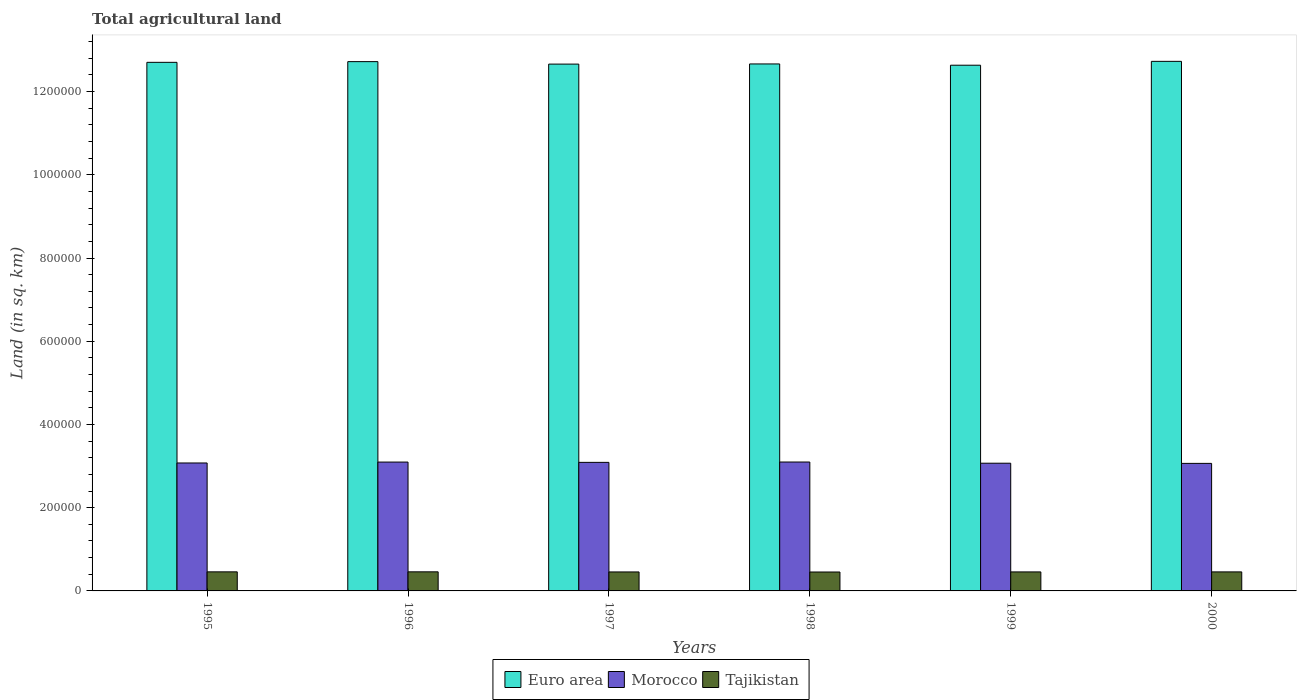How many groups of bars are there?
Provide a succinct answer. 6. Are the number of bars per tick equal to the number of legend labels?
Your answer should be very brief. Yes. Are the number of bars on each tick of the X-axis equal?
Your answer should be compact. Yes. How many bars are there on the 1st tick from the left?
Make the answer very short. 3. In how many cases, is the number of bars for a given year not equal to the number of legend labels?
Give a very brief answer. 0. What is the total agricultural land in Morocco in 2000?
Give a very brief answer. 3.07e+05. Across all years, what is the maximum total agricultural land in Tajikistan?
Make the answer very short. 4.58e+04. Across all years, what is the minimum total agricultural land in Morocco?
Your response must be concise. 3.07e+05. In which year was the total agricultural land in Tajikistan maximum?
Your response must be concise. 1996. In which year was the total agricultural land in Morocco minimum?
Give a very brief answer. 2000. What is the total total agricultural land in Morocco in the graph?
Ensure brevity in your answer.  1.85e+06. What is the difference between the total agricultural land in Morocco in 1995 and that in 1996?
Your answer should be very brief. -2170. What is the difference between the total agricultural land in Euro area in 1999 and the total agricultural land in Morocco in 1995?
Offer a very short reply. 9.56e+05. What is the average total agricultural land in Morocco per year?
Offer a terse response. 3.08e+05. In the year 1998, what is the difference between the total agricultural land in Euro area and total agricultural land in Tajikistan?
Ensure brevity in your answer.  1.22e+06. In how many years, is the total agricultural land in Morocco greater than 680000 sq.km?
Provide a short and direct response. 0. What is the ratio of the total agricultural land in Tajikistan in 1995 to that in 1996?
Keep it short and to the point. 1. Is the difference between the total agricultural land in Euro area in 1995 and 1999 greater than the difference between the total agricultural land in Tajikistan in 1995 and 1999?
Provide a succinct answer. Yes. What is the difference between the highest and the second highest total agricultural land in Euro area?
Keep it short and to the point. 653. What is the difference between the highest and the lowest total agricultural land in Euro area?
Offer a terse response. 9261. In how many years, is the total agricultural land in Morocco greater than the average total agricultural land in Morocco taken over all years?
Give a very brief answer. 3. What does the 3rd bar from the left in 1998 represents?
Offer a terse response. Tajikistan. Is it the case that in every year, the sum of the total agricultural land in Tajikistan and total agricultural land in Morocco is greater than the total agricultural land in Euro area?
Your answer should be compact. No. How many bars are there?
Provide a short and direct response. 18. How many years are there in the graph?
Give a very brief answer. 6. Does the graph contain grids?
Keep it short and to the point. No. How many legend labels are there?
Make the answer very short. 3. How are the legend labels stacked?
Provide a succinct answer. Horizontal. What is the title of the graph?
Your response must be concise. Total agricultural land. What is the label or title of the X-axis?
Provide a short and direct response. Years. What is the label or title of the Y-axis?
Your response must be concise. Land (in sq. km). What is the Land (in sq. km) in Euro area in 1995?
Your answer should be very brief. 1.27e+06. What is the Land (in sq. km) of Morocco in 1995?
Provide a short and direct response. 3.07e+05. What is the Land (in sq. km) in Tajikistan in 1995?
Keep it short and to the point. 4.58e+04. What is the Land (in sq. km) in Euro area in 1996?
Your answer should be very brief. 1.27e+06. What is the Land (in sq. km) of Morocco in 1996?
Offer a terse response. 3.10e+05. What is the Land (in sq. km) of Tajikistan in 1996?
Keep it short and to the point. 4.58e+04. What is the Land (in sq. km) of Euro area in 1997?
Your answer should be very brief. 1.27e+06. What is the Land (in sq. km) of Morocco in 1997?
Provide a short and direct response. 3.09e+05. What is the Land (in sq. km) in Tajikistan in 1997?
Your answer should be very brief. 4.56e+04. What is the Land (in sq. km) of Euro area in 1998?
Provide a succinct answer. 1.27e+06. What is the Land (in sq. km) of Morocco in 1998?
Your answer should be very brief. 3.10e+05. What is the Land (in sq. km) in Tajikistan in 1998?
Make the answer very short. 4.55e+04. What is the Land (in sq. km) in Euro area in 1999?
Your response must be concise. 1.26e+06. What is the Land (in sq. km) in Morocco in 1999?
Provide a succinct answer. 3.07e+05. What is the Land (in sq. km) of Tajikistan in 1999?
Provide a succinct answer. 4.57e+04. What is the Land (in sq. km) of Euro area in 2000?
Offer a terse response. 1.27e+06. What is the Land (in sq. km) in Morocco in 2000?
Ensure brevity in your answer.  3.07e+05. What is the Land (in sq. km) in Tajikistan in 2000?
Your answer should be very brief. 4.57e+04. Across all years, what is the maximum Land (in sq. km) in Euro area?
Provide a short and direct response. 1.27e+06. Across all years, what is the maximum Land (in sq. km) of Morocco?
Your answer should be very brief. 3.10e+05. Across all years, what is the maximum Land (in sq. km) of Tajikistan?
Offer a very short reply. 4.58e+04. Across all years, what is the minimum Land (in sq. km) of Euro area?
Ensure brevity in your answer.  1.26e+06. Across all years, what is the minimum Land (in sq. km) of Morocco?
Give a very brief answer. 3.07e+05. Across all years, what is the minimum Land (in sq. km) of Tajikistan?
Keep it short and to the point. 4.55e+04. What is the total Land (in sq. km) in Euro area in the graph?
Provide a short and direct response. 7.61e+06. What is the total Land (in sq. km) of Morocco in the graph?
Make the answer very short. 1.85e+06. What is the total Land (in sq. km) of Tajikistan in the graph?
Provide a succinct answer. 2.74e+05. What is the difference between the Land (in sq. km) of Euro area in 1995 and that in 1996?
Your response must be concise. -1692. What is the difference between the Land (in sq. km) in Morocco in 1995 and that in 1996?
Your answer should be compact. -2170. What is the difference between the Land (in sq. km) of Euro area in 1995 and that in 1997?
Ensure brevity in your answer.  4275. What is the difference between the Land (in sq. km) in Morocco in 1995 and that in 1997?
Your answer should be very brief. -1460. What is the difference between the Land (in sq. km) in Euro area in 1995 and that in 1998?
Keep it short and to the point. 3881. What is the difference between the Land (in sq. km) of Morocco in 1995 and that in 1998?
Keep it short and to the point. -2270. What is the difference between the Land (in sq. km) of Tajikistan in 1995 and that in 1998?
Provide a succinct answer. 350. What is the difference between the Land (in sq. km) in Euro area in 1995 and that in 1999?
Your answer should be compact. 6916. What is the difference between the Land (in sq. km) of Morocco in 1995 and that in 1999?
Give a very brief answer. 560. What is the difference between the Land (in sq. km) in Tajikistan in 1995 and that in 1999?
Make the answer very short. 140. What is the difference between the Land (in sq. km) in Euro area in 1995 and that in 2000?
Give a very brief answer. -2345. What is the difference between the Land (in sq. km) in Morocco in 1995 and that in 2000?
Your response must be concise. 970. What is the difference between the Land (in sq. km) of Euro area in 1996 and that in 1997?
Ensure brevity in your answer.  5967. What is the difference between the Land (in sq. km) in Morocco in 1996 and that in 1997?
Offer a terse response. 710. What is the difference between the Land (in sq. km) of Tajikistan in 1996 and that in 1997?
Give a very brief answer. 230. What is the difference between the Land (in sq. km) of Euro area in 1996 and that in 1998?
Provide a short and direct response. 5573. What is the difference between the Land (in sq. km) in Morocco in 1996 and that in 1998?
Make the answer very short. -100. What is the difference between the Land (in sq. km) in Tajikistan in 1996 and that in 1998?
Your answer should be compact. 380. What is the difference between the Land (in sq. km) in Euro area in 1996 and that in 1999?
Offer a terse response. 8608. What is the difference between the Land (in sq. km) in Morocco in 1996 and that in 1999?
Your answer should be compact. 2730. What is the difference between the Land (in sq. km) in Tajikistan in 1996 and that in 1999?
Provide a short and direct response. 170. What is the difference between the Land (in sq. km) in Euro area in 1996 and that in 2000?
Your response must be concise. -653. What is the difference between the Land (in sq. km) of Morocco in 1996 and that in 2000?
Provide a short and direct response. 3140. What is the difference between the Land (in sq. km) in Tajikistan in 1996 and that in 2000?
Keep it short and to the point. 120. What is the difference between the Land (in sq. km) in Euro area in 1997 and that in 1998?
Your response must be concise. -394. What is the difference between the Land (in sq. km) of Morocco in 1997 and that in 1998?
Your answer should be very brief. -810. What is the difference between the Land (in sq. km) of Tajikistan in 1997 and that in 1998?
Your answer should be compact. 150. What is the difference between the Land (in sq. km) of Euro area in 1997 and that in 1999?
Your response must be concise. 2641. What is the difference between the Land (in sq. km) in Morocco in 1997 and that in 1999?
Your answer should be very brief. 2020. What is the difference between the Land (in sq. km) in Tajikistan in 1997 and that in 1999?
Offer a very short reply. -60. What is the difference between the Land (in sq. km) in Euro area in 1997 and that in 2000?
Make the answer very short. -6620. What is the difference between the Land (in sq. km) of Morocco in 1997 and that in 2000?
Ensure brevity in your answer.  2430. What is the difference between the Land (in sq. km) in Tajikistan in 1997 and that in 2000?
Your answer should be very brief. -110. What is the difference between the Land (in sq. km) in Euro area in 1998 and that in 1999?
Keep it short and to the point. 3035. What is the difference between the Land (in sq. km) in Morocco in 1998 and that in 1999?
Keep it short and to the point. 2830. What is the difference between the Land (in sq. km) in Tajikistan in 1998 and that in 1999?
Your answer should be very brief. -210. What is the difference between the Land (in sq. km) of Euro area in 1998 and that in 2000?
Offer a very short reply. -6226. What is the difference between the Land (in sq. km) of Morocco in 1998 and that in 2000?
Make the answer very short. 3240. What is the difference between the Land (in sq. km) of Tajikistan in 1998 and that in 2000?
Provide a short and direct response. -260. What is the difference between the Land (in sq. km) of Euro area in 1999 and that in 2000?
Offer a very short reply. -9261. What is the difference between the Land (in sq. km) in Morocco in 1999 and that in 2000?
Keep it short and to the point. 410. What is the difference between the Land (in sq. km) of Tajikistan in 1999 and that in 2000?
Provide a short and direct response. -50. What is the difference between the Land (in sq. km) of Euro area in 1995 and the Land (in sq. km) of Morocco in 1996?
Make the answer very short. 9.61e+05. What is the difference between the Land (in sq. km) in Euro area in 1995 and the Land (in sq. km) in Tajikistan in 1996?
Give a very brief answer. 1.22e+06. What is the difference between the Land (in sq. km) in Morocco in 1995 and the Land (in sq. km) in Tajikistan in 1996?
Keep it short and to the point. 2.62e+05. What is the difference between the Land (in sq. km) in Euro area in 1995 and the Land (in sq. km) in Morocco in 1997?
Offer a very short reply. 9.61e+05. What is the difference between the Land (in sq. km) in Euro area in 1995 and the Land (in sq. km) in Tajikistan in 1997?
Ensure brevity in your answer.  1.22e+06. What is the difference between the Land (in sq. km) in Morocco in 1995 and the Land (in sq. km) in Tajikistan in 1997?
Your answer should be compact. 2.62e+05. What is the difference between the Land (in sq. km) of Euro area in 1995 and the Land (in sq. km) of Morocco in 1998?
Give a very brief answer. 9.61e+05. What is the difference between the Land (in sq. km) in Euro area in 1995 and the Land (in sq. km) in Tajikistan in 1998?
Your answer should be very brief. 1.22e+06. What is the difference between the Land (in sq. km) in Morocco in 1995 and the Land (in sq. km) in Tajikistan in 1998?
Your response must be concise. 2.62e+05. What is the difference between the Land (in sq. km) in Euro area in 1995 and the Land (in sq. km) in Morocco in 1999?
Provide a short and direct response. 9.63e+05. What is the difference between the Land (in sq. km) in Euro area in 1995 and the Land (in sq. km) in Tajikistan in 1999?
Make the answer very short. 1.22e+06. What is the difference between the Land (in sq. km) of Morocco in 1995 and the Land (in sq. km) of Tajikistan in 1999?
Your answer should be very brief. 2.62e+05. What is the difference between the Land (in sq. km) of Euro area in 1995 and the Land (in sq. km) of Morocco in 2000?
Keep it short and to the point. 9.64e+05. What is the difference between the Land (in sq. km) of Euro area in 1995 and the Land (in sq. km) of Tajikistan in 2000?
Provide a succinct answer. 1.22e+06. What is the difference between the Land (in sq. km) of Morocco in 1995 and the Land (in sq. km) of Tajikistan in 2000?
Offer a very short reply. 2.62e+05. What is the difference between the Land (in sq. km) in Euro area in 1996 and the Land (in sq. km) in Morocco in 1997?
Ensure brevity in your answer.  9.63e+05. What is the difference between the Land (in sq. km) of Euro area in 1996 and the Land (in sq. km) of Tajikistan in 1997?
Your response must be concise. 1.23e+06. What is the difference between the Land (in sq. km) of Morocco in 1996 and the Land (in sq. km) of Tajikistan in 1997?
Keep it short and to the point. 2.64e+05. What is the difference between the Land (in sq. km) in Euro area in 1996 and the Land (in sq. km) in Morocco in 1998?
Your response must be concise. 9.62e+05. What is the difference between the Land (in sq. km) in Euro area in 1996 and the Land (in sq. km) in Tajikistan in 1998?
Offer a very short reply. 1.23e+06. What is the difference between the Land (in sq. km) in Morocco in 1996 and the Land (in sq. km) in Tajikistan in 1998?
Offer a very short reply. 2.64e+05. What is the difference between the Land (in sq. km) in Euro area in 1996 and the Land (in sq. km) in Morocco in 1999?
Make the answer very short. 9.65e+05. What is the difference between the Land (in sq. km) of Euro area in 1996 and the Land (in sq. km) of Tajikistan in 1999?
Keep it short and to the point. 1.23e+06. What is the difference between the Land (in sq. km) of Morocco in 1996 and the Land (in sq. km) of Tajikistan in 1999?
Give a very brief answer. 2.64e+05. What is the difference between the Land (in sq. km) of Euro area in 1996 and the Land (in sq. km) of Morocco in 2000?
Provide a succinct answer. 9.66e+05. What is the difference between the Land (in sq. km) in Euro area in 1996 and the Land (in sq. km) in Tajikistan in 2000?
Keep it short and to the point. 1.23e+06. What is the difference between the Land (in sq. km) in Morocco in 1996 and the Land (in sq. km) in Tajikistan in 2000?
Your answer should be very brief. 2.64e+05. What is the difference between the Land (in sq. km) of Euro area in 1997 and the Land (in sq. km) of Morocco in 1998?
Offer a very short reply. 9.56e+05. What is the difference between the Land (in sq. km) in Euro area in 1997 and the Land (in sq. km) in Tajikistan in 1998?
Offer a very short reply. 1.22e+06. What is the difference between the Land (in sq. km) in Morocco in 1997 and the Land (in sq. km) in Tajikistan in 1998?
Provide a succinct answer. 2.63e+05. What is the difference between the Land (in sq. km) of Euro area in 1997 and the Land (in sq. km) of Morocco in 1999?
Your answer should be compact. 9.59e+05. What is the difference between the Land (in sq. km) in Euro area in 1997 and the Land (in sq. km) in Tajikistan in 1999?
Your response must be concise. 1.22e+06. What is the difference between the Land (in sq. km) of Morocco in 1997 and the Land (in sq. km) of Tajikistan in 1999?
Offer a terse response. 2.63e+05. What is the difference between the Land (in sq. km) in Euro area in 1997 and the Land (in sq. km) in Morocco in 2000?
Your answer should be compact. 9.60e+05. What is the difference between the Land (in sq. km) in Euro area in 1997 and the Land (in sq. km) in Tajikistan in 2000?
Your answer should be compact. 1.22e+06. What is the difference between the Land (in sq. km) in Morocco in 1997 and the Land (in sq. km) in Tajikistan in 2000?
Offer a terse response. 2.63e+05. What is the difference between the Land (in sq. km) of Euro area in 1998 and the Land (in sq. km) of Morocco in 1999?
Your answer should be compact. 9.60e+05. What is the difference between the Land (in sq. km) in Euro area in 1998 and the Land (in sq. km) in Tajikistan in 1999?
Provide a short and direct response. 1.22e+06. What is the difference between the Land (in sq. km) of Morocco in 1998 and the Land (in sq. km) of Tajikistan in 1999?
Your response must be concise. 2.64e+05. What is the difference between the Land (in sq. km) in Euro area in 1998 and the Land (in sq. km) in Morocco in 2000?
Offer a very short reply. 9.60e+05. What is the difference between the Land (in sq. km) in Euro area in 1998 and the Land (in sq. km) in Tajikistan in 2000?
Give a very brief answer. 1.22e+06. What is the difference between the Land (in sq. km) of Morocco in 1998 and the Land (in sq. km) of Tajikistan in 2000?
Provide a short and direct response. 2.64e+05. What is the difference between the Land (in sq. km) in Euro area in 1999 and the Land (in sq. km) in Morocco in 2000?
Keep it short and to the point. 9.57e+05. What is the difference between the Land (in sq. km) of Euro area in 1999 and the Land (in sq. km) of Tajikistan in 2000?
Offer a terse response. 1.22e+06. What is the difference between the Land (in sq. km) in Morocco in 1999 and the Land (in sq. km) in Tajikistan in 2000?
Provide a short and direct response. 2.61e+05. What is the average Land (in sq. km) in Euro area per year?
Make the answer very short. 1.27e+06. What is the average Land (in sq. km) of Morocco per year?
Offer a terse response. 3.08e+05. What is the average Land (in sq. km) in Tajikistan per year?
Offer a very short reply. 4.57e+04. In the year 1995, what is the difference between the Land (in sq. km) of Euro area and Land (in sq. km) of Morocco?
Offer a very short reply. 9.63e+05. In the year 1995, what is the difference between the Land (in sq. km) in Euro area and Land (in sq. km) in Tajikistan?
Keep it short and to the point. 1.22e+06. In the year 1995, what is the difference between the Land (in sq. km) in Morocco and Land (in sq. km) in Tajikistan?
Offer a very short reply. 2.62e+05. In the year 1996, what is the difference between the Land (in sq. km) of Euro area and Land (in sq. km) of Morocco?
Offer a very short reply. 9.62e+05. In the year 1996, what is the difference between the Land (in sq. km) of Euro area and Land (in sq. km) of Tajikistan?
Keep it short and to the point. 1.23e+06. In the year 1996, what is the difference between the Land (in sq. km) of Morocco and Land (in sq. km) of Tajikistan?
Your answer should be compact. 2.64e+05. In the year 1997, what is the difference between the Land (in sq. km) of Euro area and Land (in sq. km) of Morocco?
Make the answer very short. 9.57e+05. In the year 1997, what is the difference between the Land (in sq. km) of Euro area and Land (in sq. km) of Tajikistan?
Make the answer very short. 1.22e+06. In the year 1997, what is the difference between the Land (in sq. km) in Morocco and Land (in sq. km) in Tajikistan?
Your answer should be compact. 2.63e+05. In the year 1998, what is the difference between the Land (in sq. km) in Euro area and Land (in sq. km) in Morocco?
Give a very brief answer. 9.57e+05. In the year 1998, what is the difference between the Land (in sq. km) in Euro area and Land (in sq. km) in Tajikistan?
Ensure brevity in your answer.  1.22e+06. In the year 1998, what is the difference between the Land (in sq. km) of Morocco and Land (in sq. km) of Tajikistan?
Offer a very short reply. 2.64e+05. In the year 1999, what is the difference between the Land (in sq. km) of Euro area and Land (in sq. km) of Morocco?
Give a very brief answer. 9.56e+05. In the year 1999, what is the difference between the Land (in sq. km) in Euro area and Land (in sq. km) in Tajikistan?
Your answer should be compact. 1.22e+06. In the year 1999, what is the difference between the Land (in sq. km) of Morocco and Land (in sq. km) of Tajikistan?
Your answer should be very brief. 2.61e+05. In the year 2000, what is the difference between the Land (in sq. km) of Euro area and Land (in sq. km) of Morocco?
Your response must be concise. 9.66e+05. In the year 2000, what is the difference between the Land (in sq. km) in Euro area and Land (in sq. km) in Tajikistan?
Make the answer very short. 1.23e+06. In the year 2000, what is the difference between the Land (in sq. km) of Morocco and Land (in sq. km) of Tajikistan?
Your answer should be very brief. 2.61e+05. What is the ratio of the Land (in sq. km) of Euro area in 1995 to that in 1996?
Your response must be concise. 1. What is the ratio of the Land (in sq. km) of Morocco in 1995 to that in 1996?
Provide a succinct answer. 0.99. What is the ratio of the Land (in sq. km) of Tajikistan in 1995 to that in 1996?
Your answer should be compact. 1. What is the ratio of the Land (in sq. km) of Euro area in 1995 to that in 1997?
Provide a short and direct response. 1. What is the ratio of the Land (in sq. km) of Morocco in 1995 to that in 1997?
Give a very brief answer. 1. What is the ratio of the Land (in sq. km) of Tajikistan in 1995 to that in 1998?
Offer a very short reply. 1.01. What is the ratio of the Land (in sq. km) of Morocco in 1995 to that in 1999?
Offer a very short reply. 1. What is the ratio of the Land (in sq. km) of Tajikistan in 1995 to that in 1999?
Keep it short and to the point. 1. What is the ratio of the Land (in sq. km) of Euro area in 1996 to that in 1997?
Your answer should be very brief. 1. What is the ratio of the Land (in sq. km) of Euro area in 1996 to that in 1998?
Keep it short and to the point. 1. What is the ratio of the Land (in sq. km) in Morocco in 1996 to that in 1998?
Make the answer very short. 1. What is the ratio of the Land (in sq. km) of Tajikistan in 1996 to that in 1998?
Your response must be concise. 1.01. What is the ratio of the Land (in sq. km) of Euro area in 1996 to that in 1999?
Give a very brief answer. 1.01. What is the ratio of the Land (in sq. km) in Morocco in 1996 to that in 1999?
Provide a short and direct response. 1.01. What is the ratio of the Land (in sq. km) of Morocco in 1996 to that in 2000?
Offer a very short reply. 1.01. What is the ratio of the Land (in sq. km) of Tajikistan in 1996 to that in 2000?
Your answer should be very brief. 1. What is the ratio of the Land (in sq. km) of Tajikistan in 1997 to that in 1998?
Provide a short and direct response. 1. What is the ratio of the Land (in sq. km) of Morocco in 1997 to that in 1999?
Offer a very short reply. 1.01. What is the ratio of the Land (in sq. km) of Tajikistan in 1997 to that in 1999?
Make the answer very short. 1. What is the ratio of the Land (in sq. km) of Euro area in 1997 to that in 2000?
Your answer should be very brief. 0.99. What is the ratio of the Land (in sq. km) of Morocco in 1997 to that in 2000?
Make the answer very short. 1.01. What is the ratio of the Land (in sq. km) of Morocco in 1998 to that in 1999?
Your response must be concise. 1.01. What is the ratio of the Land (in sq. km) in Tajikistan in 1998 to that in 1999?
Your answer should be compact. 1. What is the ratio of the Land (in sq. km) in Euro area in 1998 to that in 2000?
Offer a terse response. 1. What is the ratio of the Land (in sq. km) of Morocco in 1998 to that in 2000?
Make the answer very short. 1.01. What is the ratio of the Land (in sq. km) of Euro area in 1999 to that in 2000?
Provide a short and direct response. 0.99. What is the ratio of the Land (in sq. km) in Morocco in 1999 to that in 2000?
Offer a terse response. 1. What is the ratio of the Land (in sq. km) in Tajikistan in 1999 to that in 2000?
Give a very brief answer. 1. What is the difference between the highest and the second highest Land (in sq. km) of Euro area?
Your answer should be very brief. 653. What is the difference between the highest and the lowest Land (in sq. km) of Euro area?
Your answer should be compact. 9261. What is the difference between the highest and the lowest Land (in sq. km) of Morocco?
Your response must be concise. 3240. What is the difference between the highest and the lowest Land (in sq. km) in Tajikistan?
Ensure brevity in your answer.  380. 